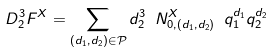<formula> <loc_0><loc_0><loc_500><loc_500>D _ { 2 } ^ { 3 } F ^ { X } = \sum _ { ( d _ { 1 } , d _ { 2 } ) \in \mathcal { P } } d _ { 2 } ^ { 3 } \ N ^ { X } _ { 0 , ( d _ { 1 } , d _ { 2 } ) } \ q _ { 1 } ^ { d _ { 1 } } q _ { 2 } ^ { d _ { 2 } }</formula> 